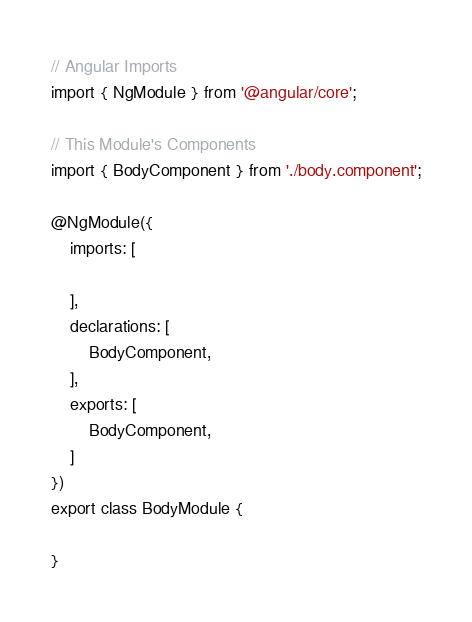Convert code to text. <code><loc_0><loc_0><loc_500><loc_500><_TypeScript_>// Angular Imports
import { NgModule } from '@angular/core';

// This Module's Components
import { BodyComponent } from './body.component';

@NgModule({
    imports: [

    ],
    declarations: [
        BodyComponent,
    ],
    exports: [
        BodyComponent,
    ]
})
export class BodyModule {

}
</code> 